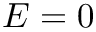Convert formula to latex. <formula><loc_0><loc_0><loc_500><loc_500>E = 0</formula> 